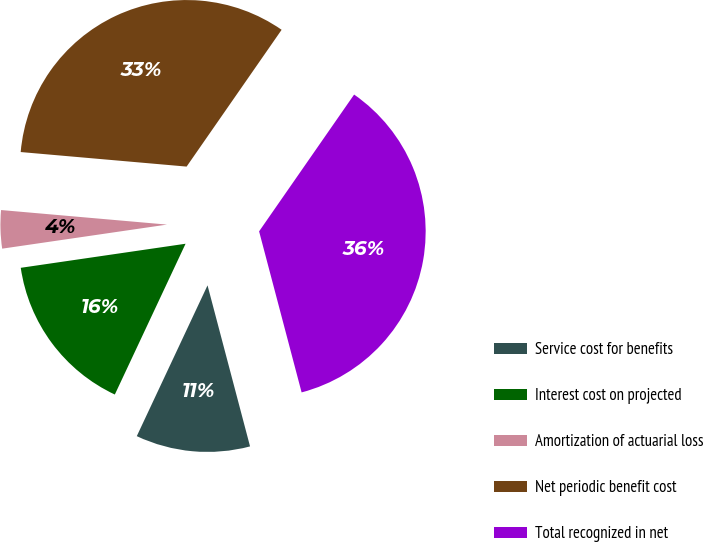Convert chart to OTSL. <chart><loc_0><loc_0><loc_500><loc_500><pie_chart><fcel>Service cost for benefits<fcel>Interest cost on projected<fcel>Amortization of actuarial loss<fcel>Net periodic benefit cost<fcel>Total recognized in net<nl><fcel>11.09%<fcel>15.71%<fcel>3.7%<fcel>33.27%<fcel>36.23%<nl></chart> 